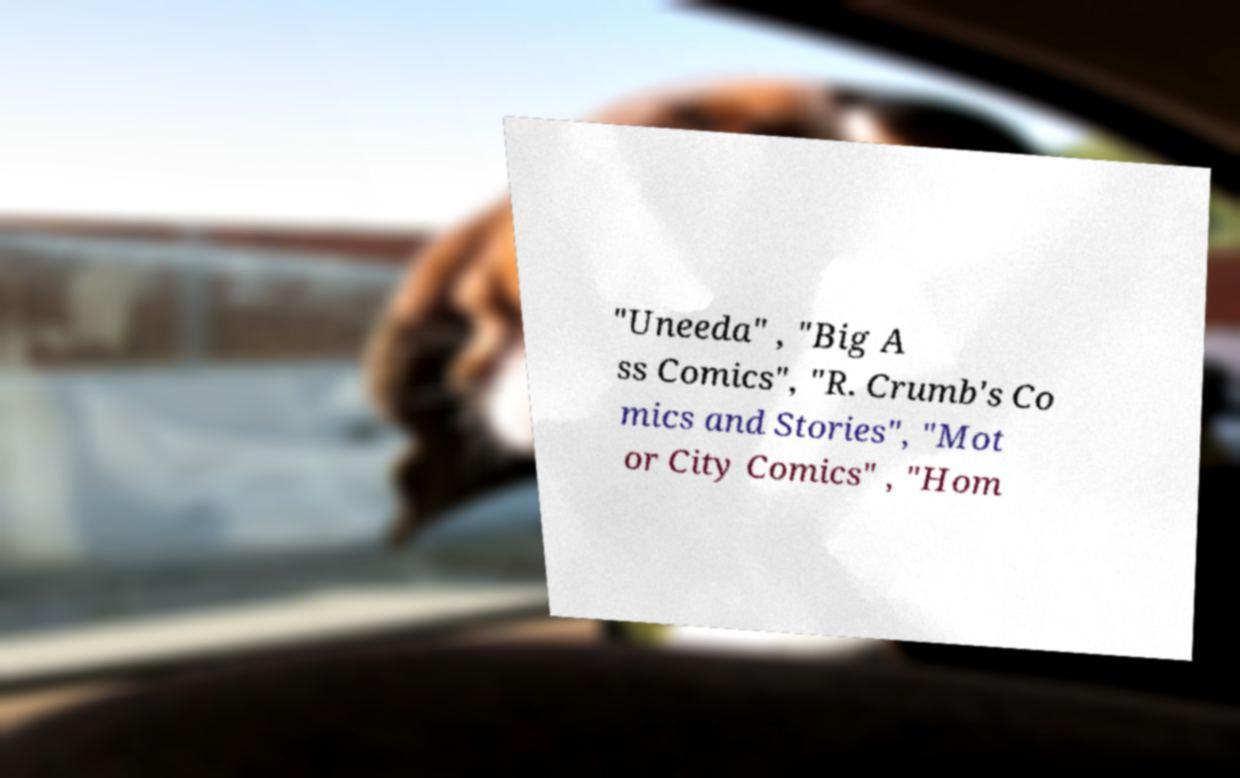For documentation purposes, I need the text within this image transcribed. Could you provide that? "Uneeda" , "Big A ss Comics", "R. Crumb's Co mics and Stories", "Mot or City Comics" , "Hom 